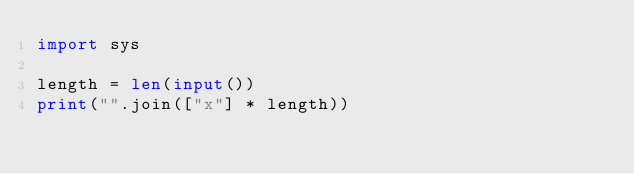Convert code to text. <code><loc_0><loc_0><loc_500><loc_500><_Python_>import sys

length = len(input())
print("".join(["x"] * length))</code> 